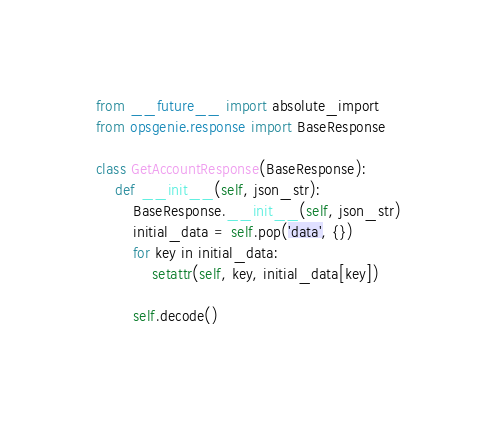Convert code to text. <code><loc_0><loc_0><loc_500><loc_500><_Python_>from __future__ import absolute_import
from opsgenie.response import BaseResponse

class GetAccountResponse(BaseResponse):
    def __init__(self, json_str):
        BaseResponse.__init__(self, json_str)
        initial_data = self.pop('data', {})
        for key in initial_data:
            setattr(self, key, initial_data[key])

        self.decode()
</code> 